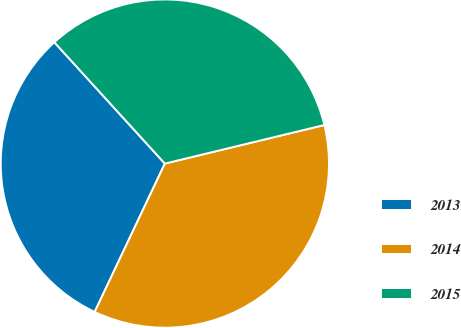Convert chart to OTSL. <chart><loc_0><loc_0><loc_500><loc_500><pie_chart><fcel>2013<fcel>2014<fcel>2015<nl><fcel>31.21%<fcel>35.81%<fcel>32.98%<nl></chart> 